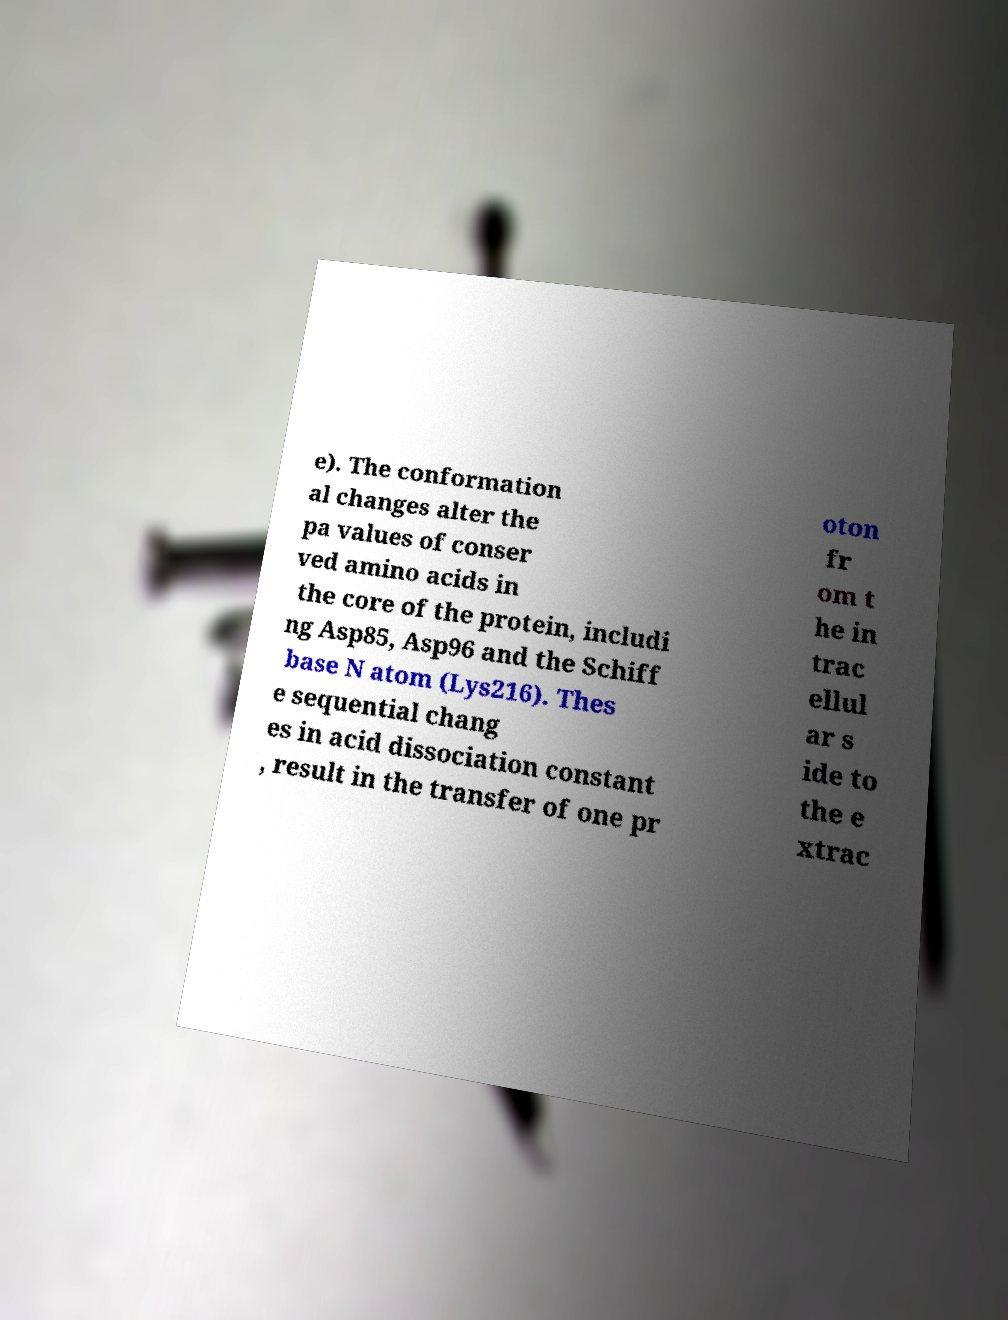Can you read and provide the text displayed in the image?This photo seems to have some interesting text. Can you extract and type it out for me? e). The conformation al changes alter the pa values of conser ved amino acids in the core of the protein, includi ng Asp85, Asp96 and the Schiff base N atom (Lys216). Thes e sequential chang es in acid dissociation constant , result in the transfer of one pr oton fr om t he in trac ellul ar s ide to the e xtrac 